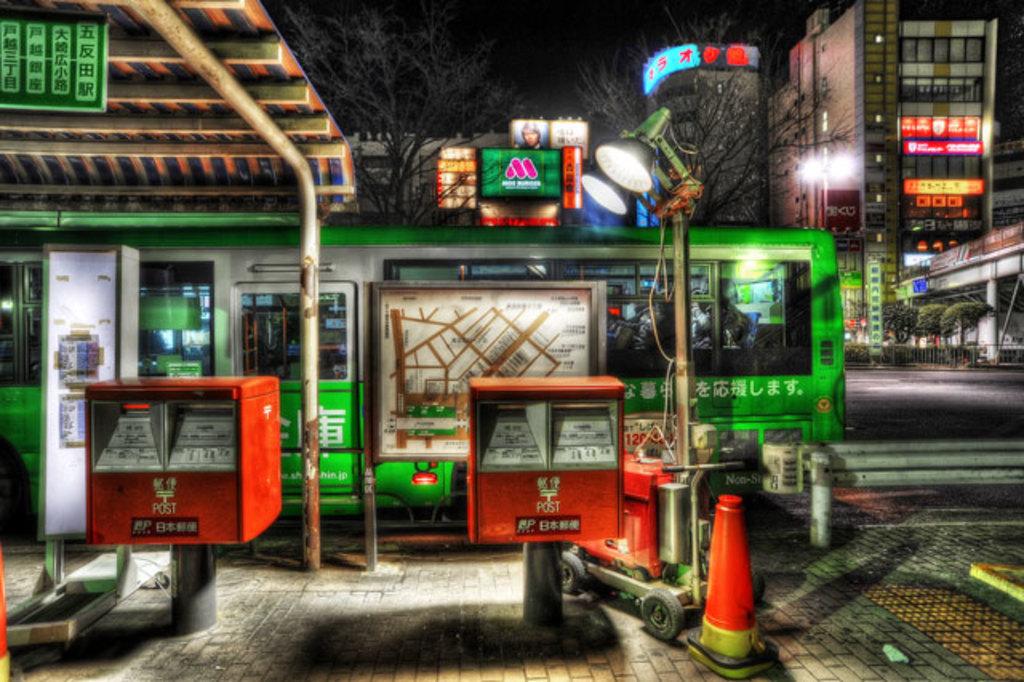What is written on front of the red boxes?
Provide a succinct answer. Post. 